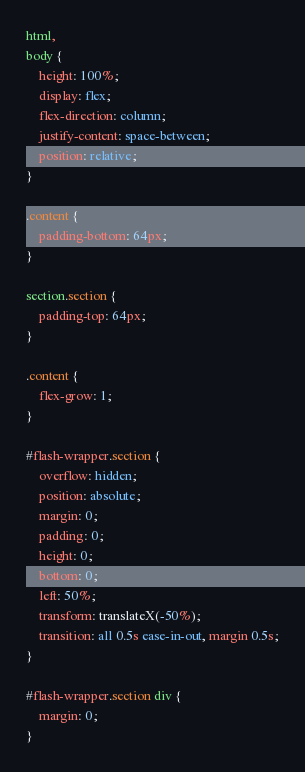Convert code to text. <code><loc_0><loc_0><loc_500><loc_500><_CSS_>html,
body {
    height: 100%;
    display: flex;
    flex-direction: column;
    justify-content: space-between;
    position: relative;
}

.content {
    padding-bottom: 64px;
}

section.section {
    padding-top: 64px;
}

.content {
    flex-grow: 1;
}

#flash-wrapper.section {
    overflow: hidden;
    position: absolute;
    margin: 0;
    padding: 0;
    height: 0;
    bottom: 0;
    left: 50%;
    transform: translateX(-50%);
    transition: all 0.5s ease-in-out, margin 0.5s;
}

#flash-wrapper.section div {
    margin: 0;
}
</code> 